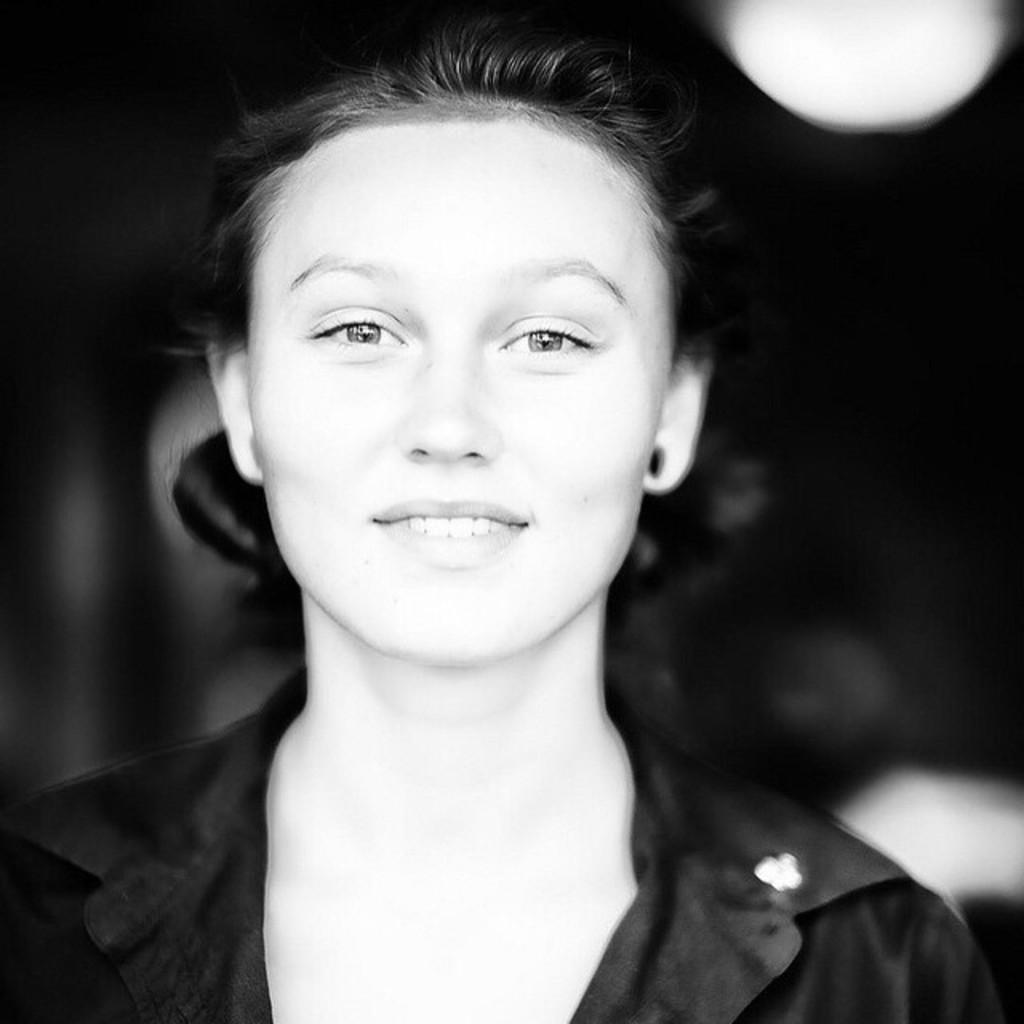What is the main subject of the image? There is a person in the image. Can you describe the background of the image? The background of the image is blurred. What color scheme is used in the image? The image is in black and white. What type of lettuce can be seen growing on the moon in the image? There is no lettuce or moon present in the image; it features a person with a blurred background in black and white. 